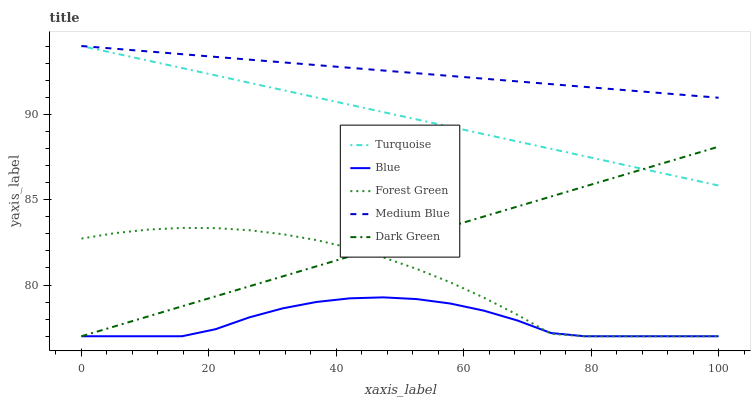Does Turquoise have the minimum area under the curve?
Answer yes or no. No. Does Turquoise have the maximum area under the curve?
Answer yes or no. No. Is Turquoise the smoothest?
Answer yes or no. No. Is Turquoise the roughest?
Answer yes or no. No. Does Turquoise have the lowest value?
Answer yes or no. No. Does Forest Green have the highest value?
Answer yes or no. No. Is Blue less than Turquoise?
Answer yes or no. Yes. Is Medium Blue greater than Dark Green?
Answer yes or no. Yes. Does Blue intersect Turquoise?
Answer yes or no. No. 